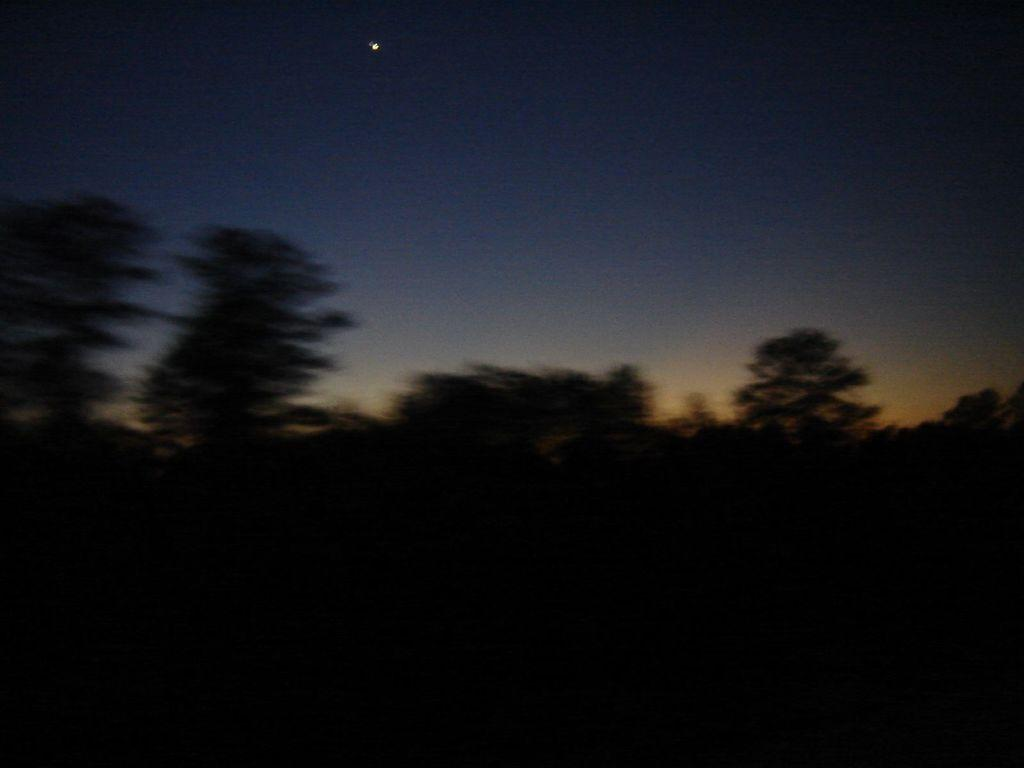What celestial object can be seen in the sky in the image? The moon is visible in the sky in the image. What type of vegetation is present in the image? There are trees in the middle of the image. How would you describe the lighting in the bottom part of the image? The bottom of the image appears to be dark. What type of berry is growing on the moon in the image? There are no berries present on the moon in the image. Can you see the nose of the person standing next to the trees in the image? There is no person present in the image, so it is not possible to see their nose. 